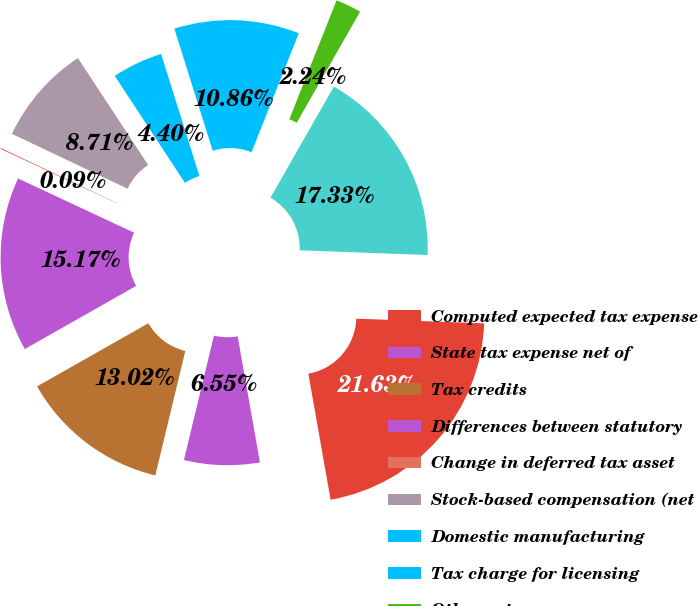<chart> <loc_0><loc_0><loc_500><loc_500><pie_chart><fcel>Computed expected tax expense<fcel>State tax expense net of<fcel>Tax credits<fcel>Differences between statutory<fcel>Change in deferred tax asset<fcel>Stock-based compensation (net<fcel>Domestic manufacturing<fcel>Tax charge for licensing<fcel>Other net<fcel>Provision for income taxes<nl><fcel>21.63%<fcel>6.55%<fcel>13.02%<fcel>15.17%<fcel>0.09%<fcel>8.71%<fcel>4.4%<fcel>10.86%<fcel>2.24%<fcel>17.33%<nl></chart> 